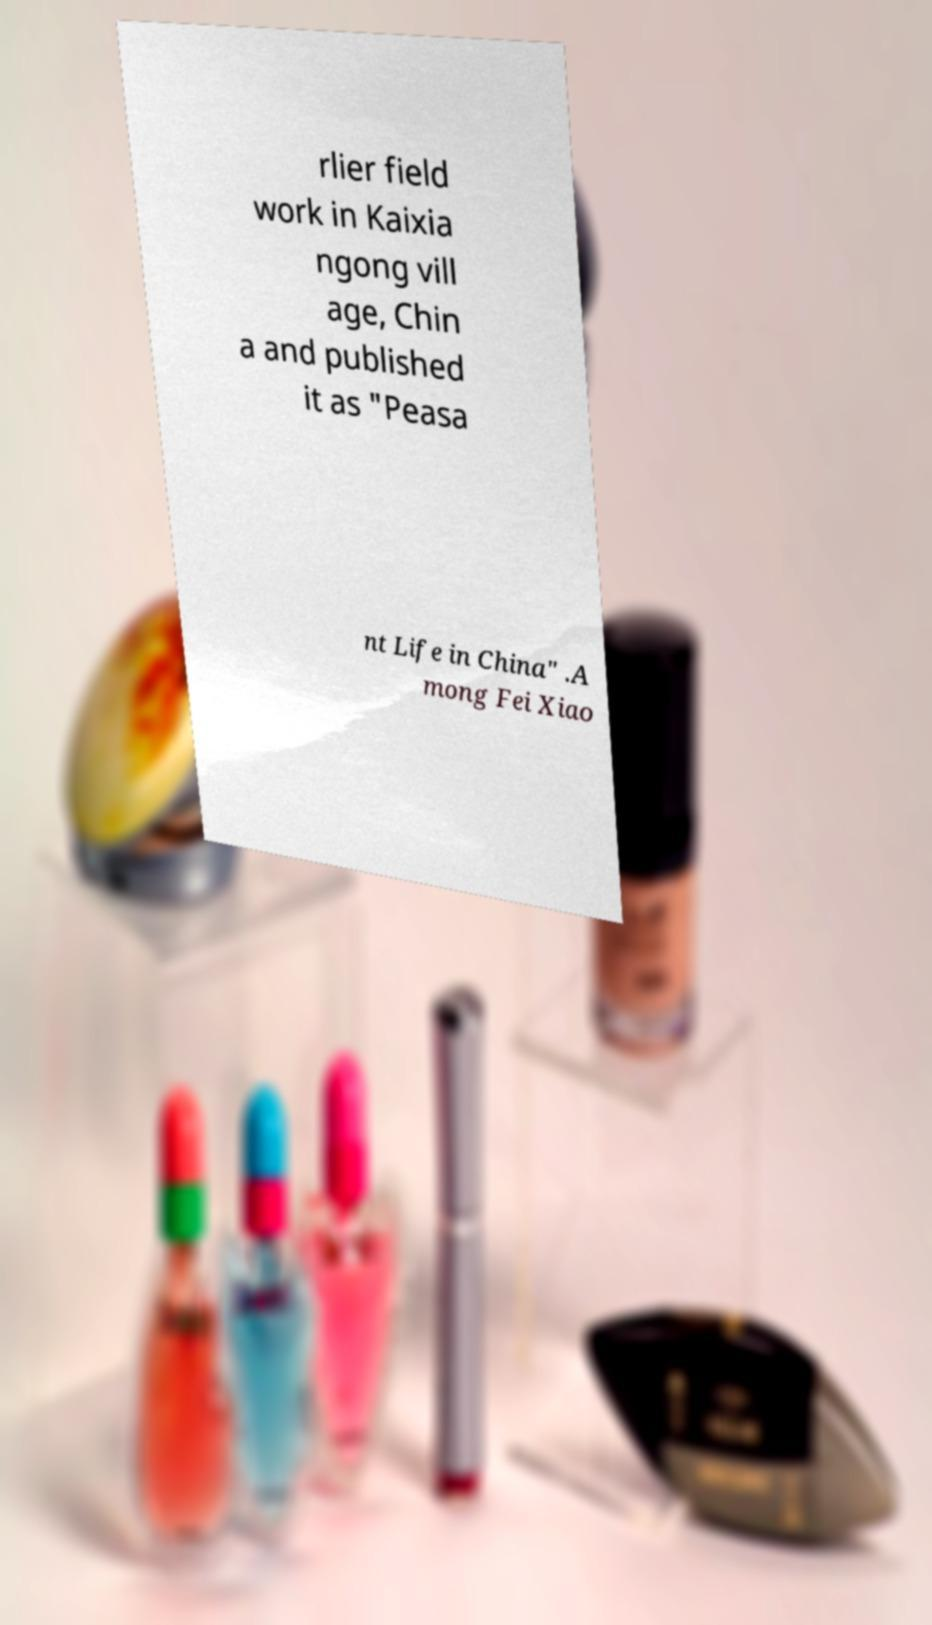Please read and relay the text visible in this image. What does it say? rlier field work in Kaixia ngong vill age, Chin a and published it as "Peasa nt Life in China" .A mong Fei Xiao 